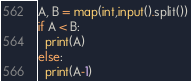Convert code to text. <code><loc_0><loc_0><loc_500><loc_500><_Python_>A, B = map(int,input().split())
if A < B:
  print(A)
else:
  print(A-1)</code> 